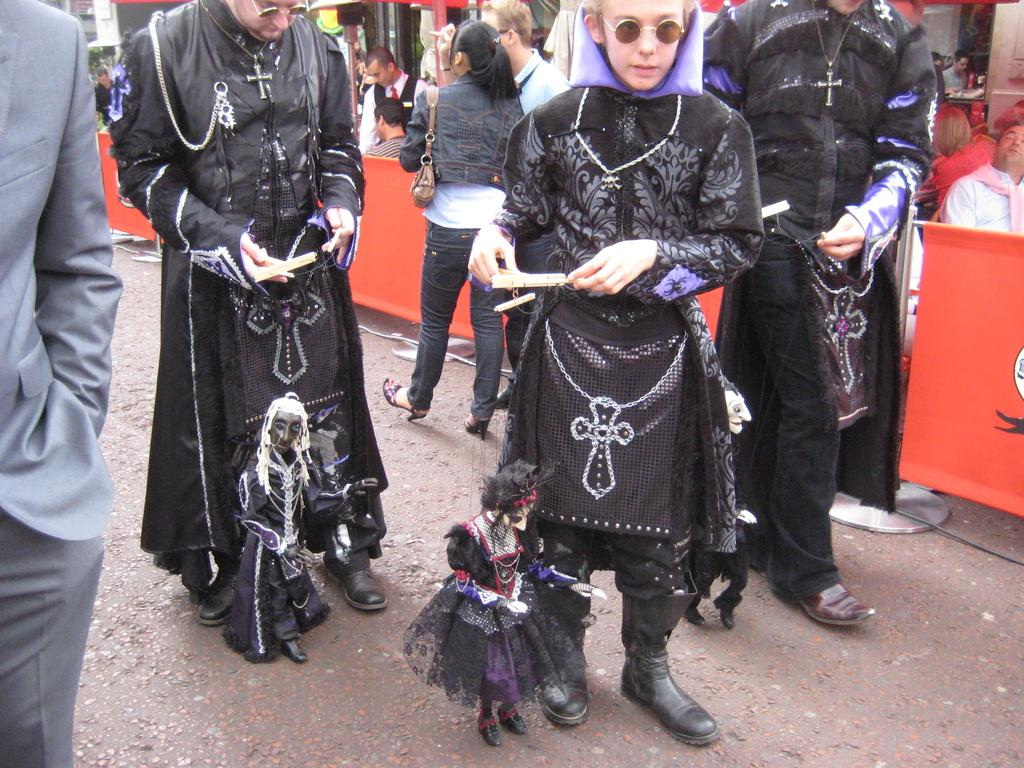Who or what can be seen in the image? There are people in the image. What are some of the people holding? Some people are holding puppets. What can be seen in the distance in the image? There is a road visible in the image. What are the boards used for in the image? The boards are not specified in the facts, but they are present in the image. What else can be seen in the background of the image? There are objects in the background of the image. Who is wearing the crown in the image? There is no crown present in the image. What discovery was made by the team in the image? There is no team or discovery mentioned in the image. 